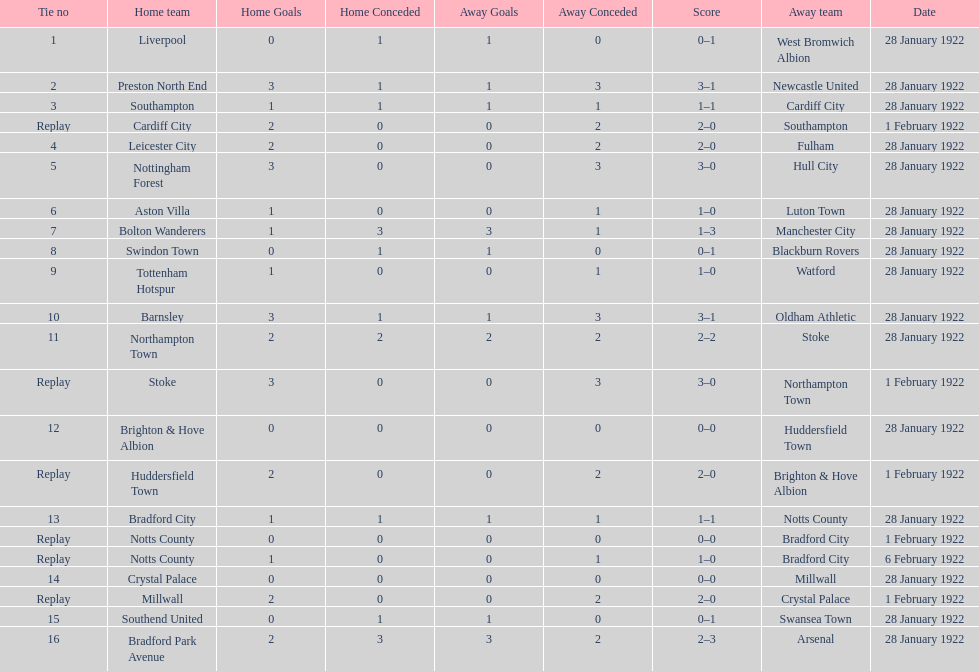How many total points were scored in the second round proper? 45. 